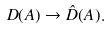<formula> <loc_0><loc_0><loc_500><loc_500>D ( A ) \rightarrow \hat { D } ( A ) .</formula> 